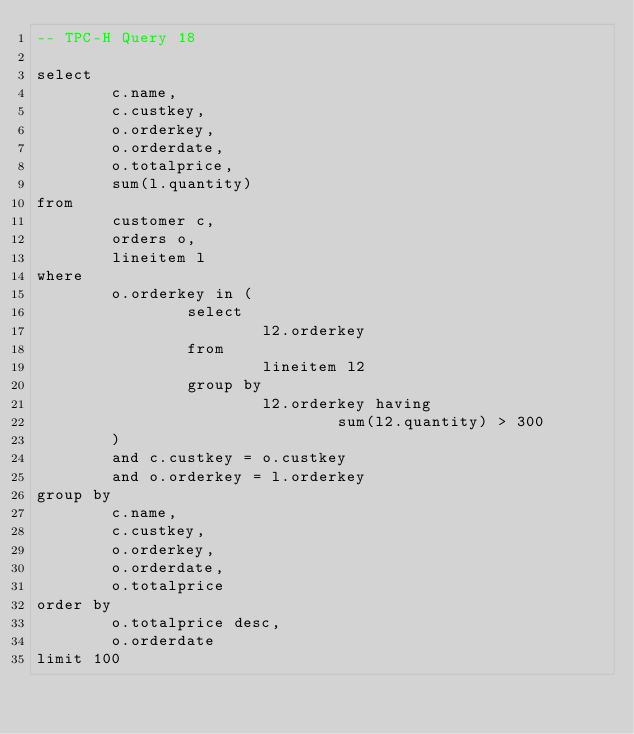<code> <loc_0><loc_0><loc_500><loc_500><_SQL_>-- TPC-H Query 18

select
        c.name,
        c.custkey,
        o.orderkey,
        o.orderdate,
        o.totalprice,
        sum(l.quantity)
from
        customer c,
        orders o,
        lineitem l
where
        o.orderkey in (
                select
                        l2.orderkey
                from
                        lineitem l2
                group by
                        l2.orderkey having
                                sum(l2.quantity) > 300
        )
        and c.custkey = o.custkey
        and o.orderkey = l.orderkey
group by
        c.name,
        c.custkey,
        o.orderkey,
        o.orderdate,
        o.totalprice
order by
        o.totalprice desc,
        o.orderdate
limit 100
</code> 